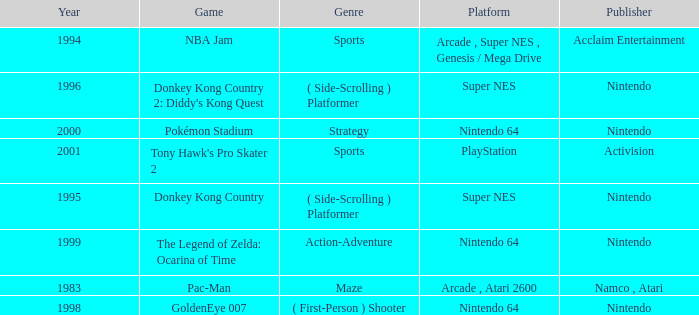Which Genre has a Game of tony hawk's pro skater 2? Sports. 